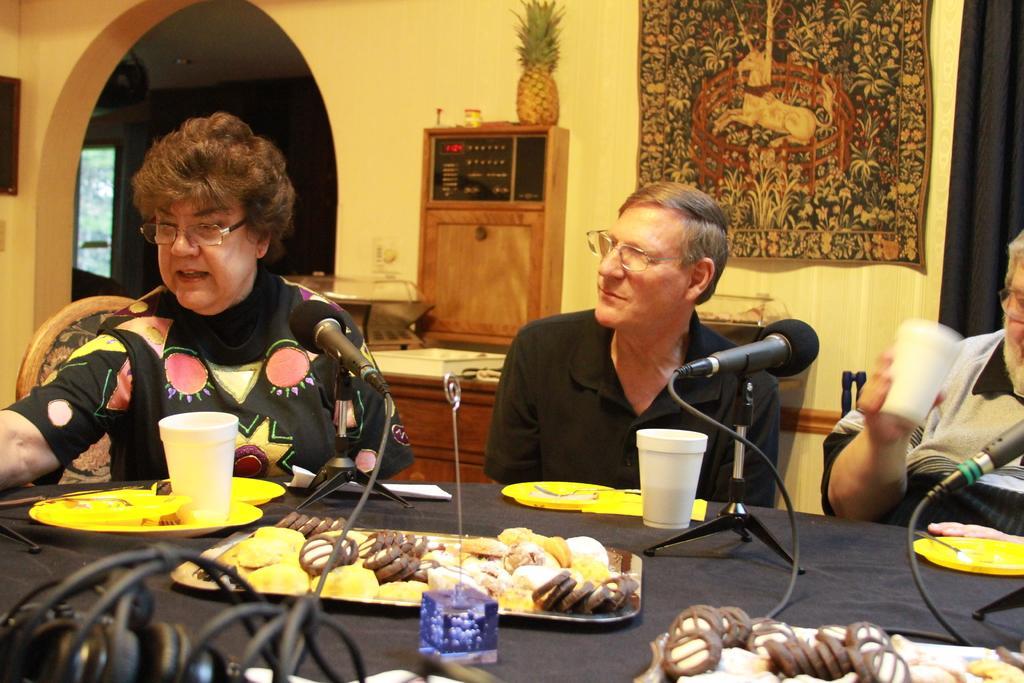Please provide a concise description of this image. In this image i can see three persons sitting on chairs in front of a table. On the table i can see few microphones, few cups, few plates and some food items. In the background i can see a wall, a cloth, a pineapple and few books. 